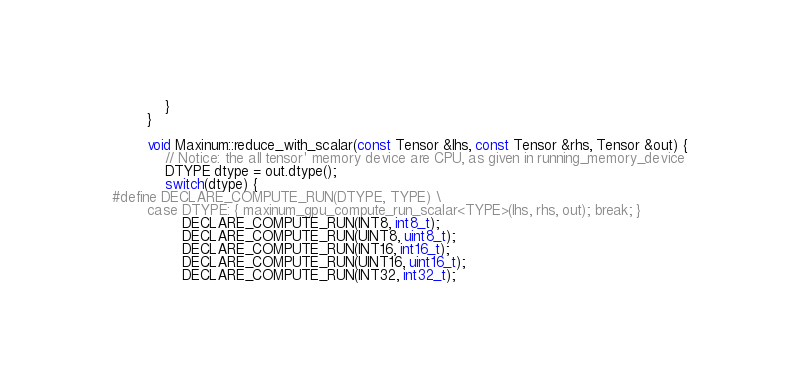Convert code to text. <code><loc_0><loc_0><loc_500><loc_500><_Cuda_>            }
        }

        void Maxinum::reduce_with_scalar(const Tensor &lhs, const Tensor &rhs, Tensor &out) {
            // Notice: the all tensor' memory device are CPU, as given in running_memory_device
            DTYPE dtype = out.dtype();
            switch(dtype) {
#define DECLARE_COMPUTE_RUN(DTYPE, TYPE) \
        case DTYPE: { maxinum_gpu_compute_run_scalar<TYPE>(lhs, rhs, out); break; }
                DECLARE_COMPUTE_RUN(INT8, int8_t);
                DECLARE_COMPUTE_RUN(UINT8, uint8_t);
                DECLARE_COMPUTE_RUN(INT16, int16_t);
                DECLARE_COMPUTE_RUN(UINT16, uint16_t);
                DECLARE_COMPUTE_RUN(INT32, int32_t);</code> 